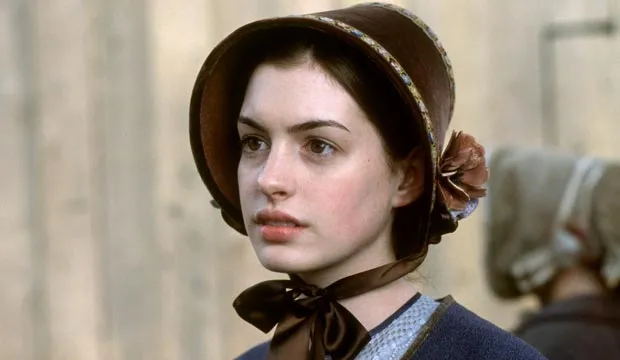Can you describe the mood or setting conveyed in this image? The image conveys a serious and historical mood. The woman’s period costume suggests that she might be a character from a historical film or reenactment. The serious expression on her face, combined with the blurred background figure, adds a sense of depth and possibly tension to the scene. What time period does her attire suggest? Her attire, featuring a blue dress with a bonnet and a black ribbon around her neck, suggests a setting from the 18th or early 19th century. This type of period costume was commonly worn during this era, particularly in rural or smaller town settings. Imagine a story behind this snapshot. What could be happening? In a small 18th-century village, a young woman named Eleanor is standing by the edge of a market square. She gazes into the distance, reflecting on her upcoming arranged marriage to a man she barely knows. The bustle of the market fades into the background as she contemplates her uncertain future and the choices she might have to make to find true happiness. The figure in the background is her younger brother, watching anxiously, knowing that this marriage could either secure or ruin their family's fortunes. 